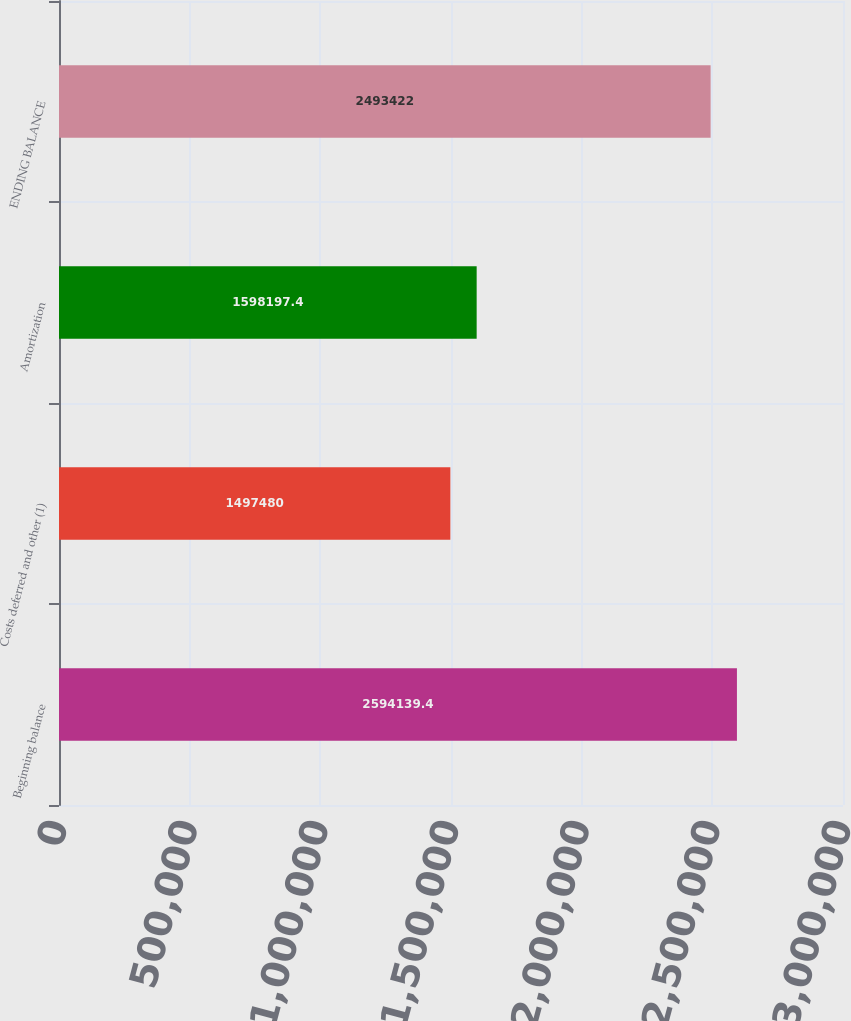Convert chart. <chart><loc_0><loc_0><loc_500><loc_500><bar_chart><fcel>Beginning balance<fcel>Costs deferred and other (1)<fcel>Amortization<fcel>ENDING BALANCE<nl><fcel>2.59414e+06<fcel>1.49748e+06<fcel>1.5982e+06<fcel>2.49342e+06<nl></chart> 